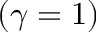<formula> <loc_0><loc_0><loc_500><loc_500>( \gamma = 1 )</formula> 